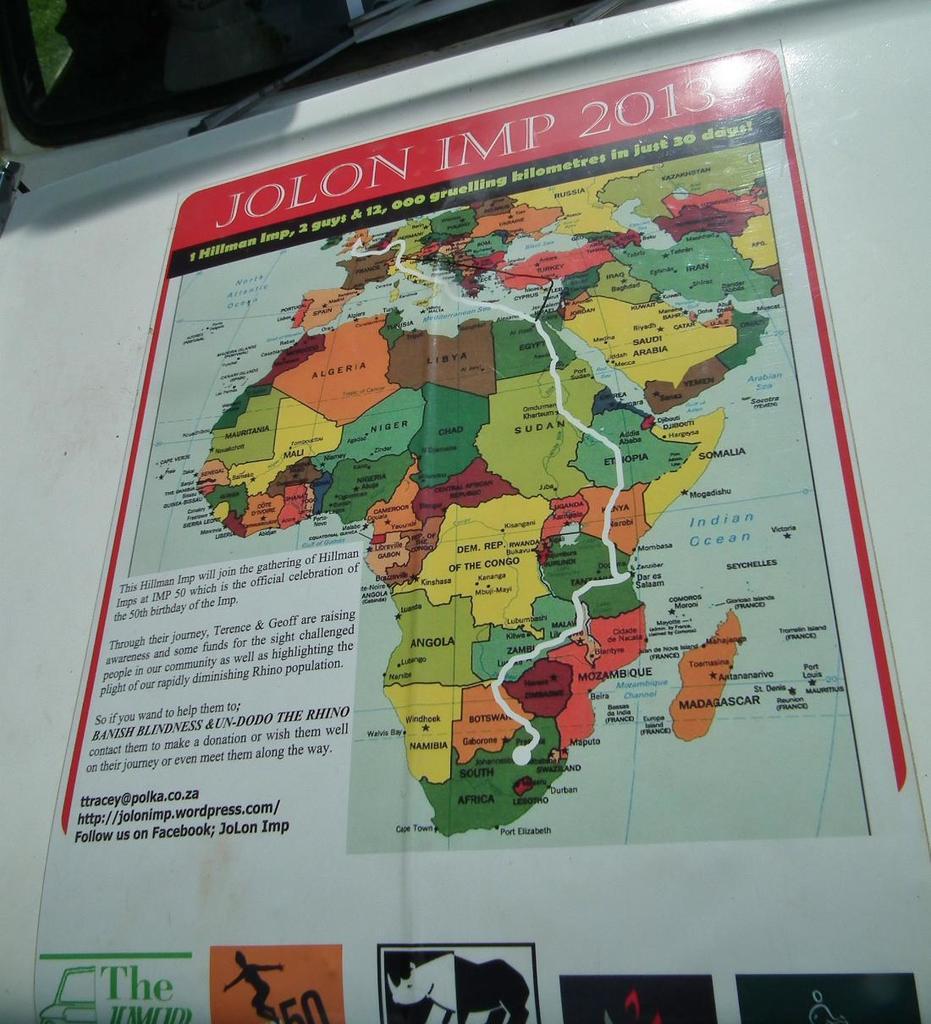Which country is bounded by ethiopia, kenya and the indian ocean?
Keep it short and to the point. Somalia. What is the date at the top of the map?
Offer a terse response. 2013. 